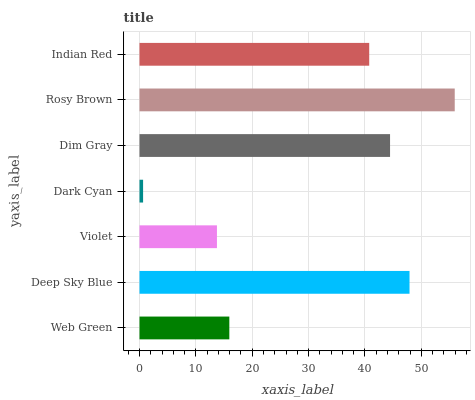Is Dark Cyan the minimum?
Answer yes or no. Yes. Is Rosy Brown the maximum?
Answer yes or no. Yes. Is Deep Sky Blue the minimum?
Answer yes or no. No. Is Deep Sky Blue the maximum?
Answer yes or no. No. Is Deep Sky Blue greater than Web Green?
Answer yes or no. Yes. Is Web Green less than Deep Sky Blue?
Answer yes or no. Yes. Is Web Green greater than Deep Sky Blue?
Answer yes or no. No. Is Deep Sky Blue less than Web Green?
Answer yes or no. No. Is Indian Red the high median?
Answer yes or no. Yes. Is Indian Red the low median?
Answer yes or no. Yes. Is Dim Gray the high median?
Answer yes or no. No. Is Web Green the low median?
Answer yes or no. No. 